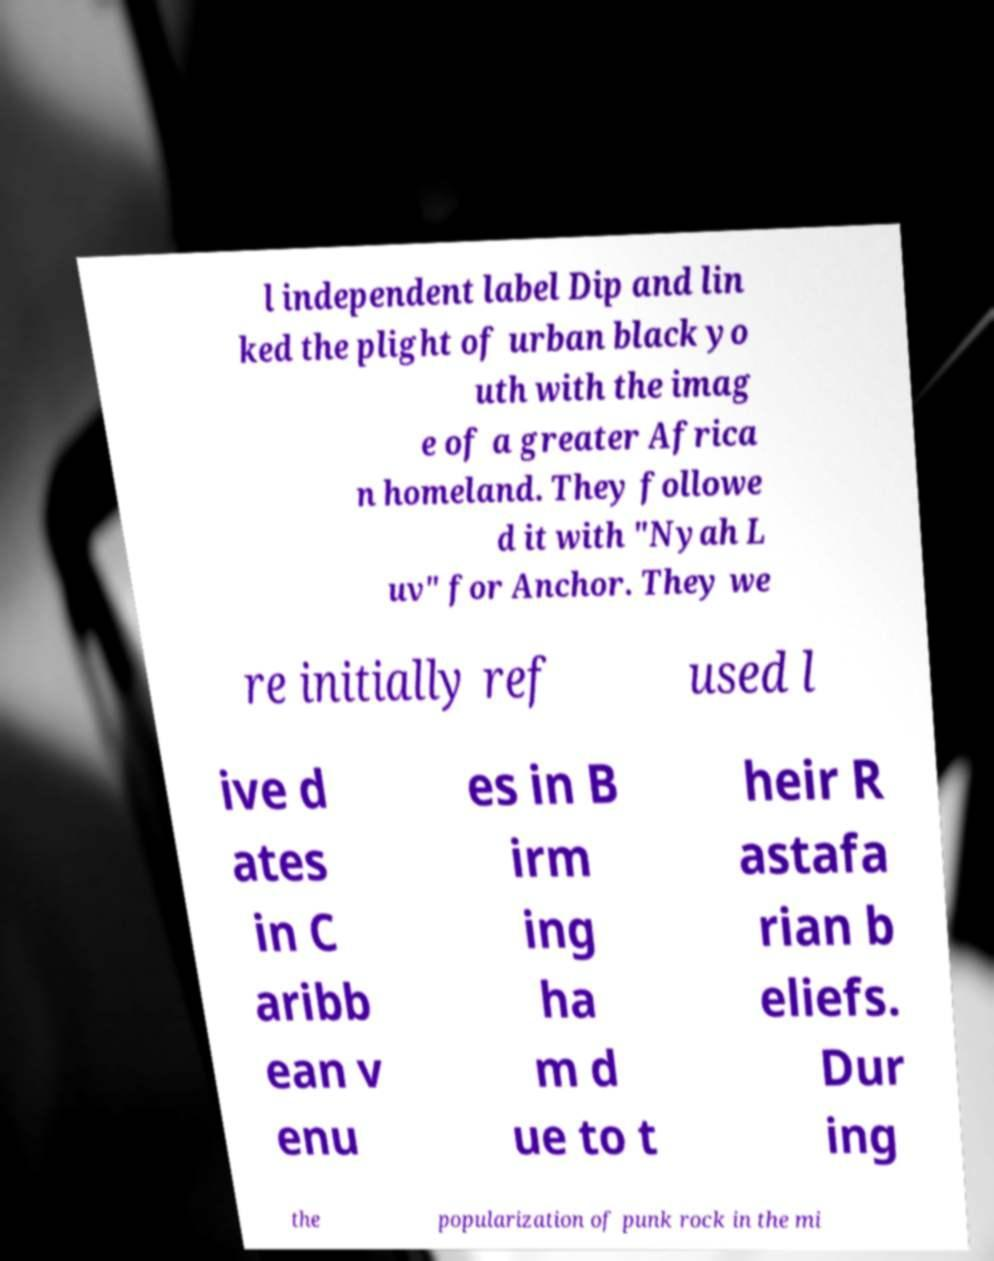I need the written content from this picture converted into text. Can you do that? l independent label Dip and lin ked the plight of urban black yo uth with the imag e of a greater Africa n homeland. They followe d it with "Nyah L uv" for Anchor. They we re initially ref used l ive d ates in C aribb ean v enu es in B irm ing ha m d ue to t heir R astafa rian b eliefs. Dur ing the popularization of punk rock in the mi 